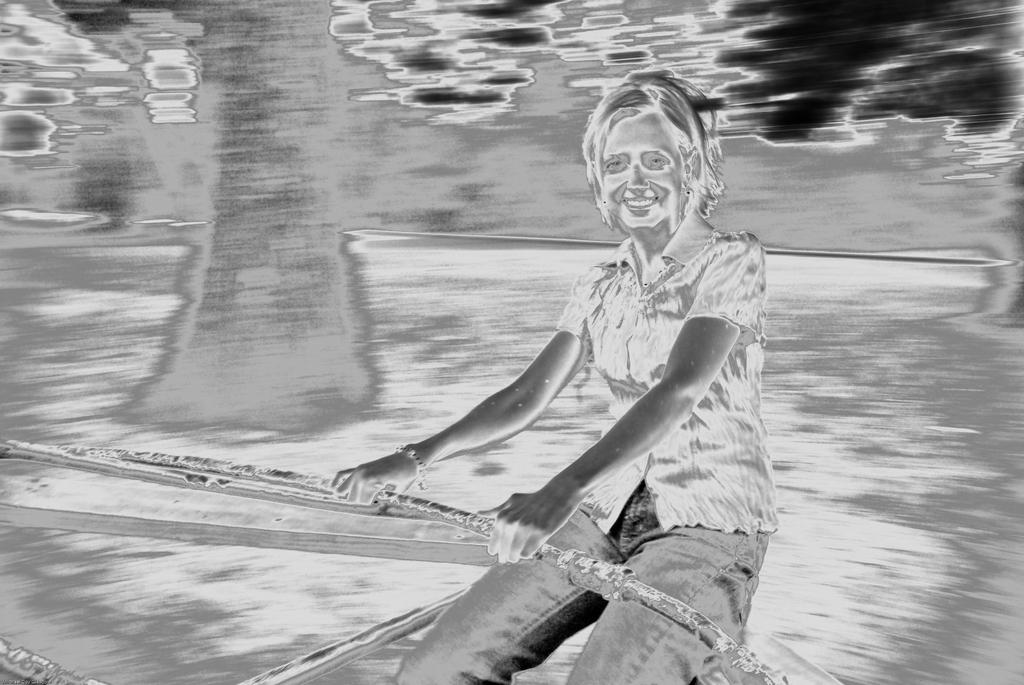Who is present in the image? There is a woman in the image. What is the woman doing in the image? The woman is sitting on a seesaw and smiling. What type of vase is being sold at the market in the image? There is no market or vase present in the image; it features a woman sitting on a seesaw and smiling. 